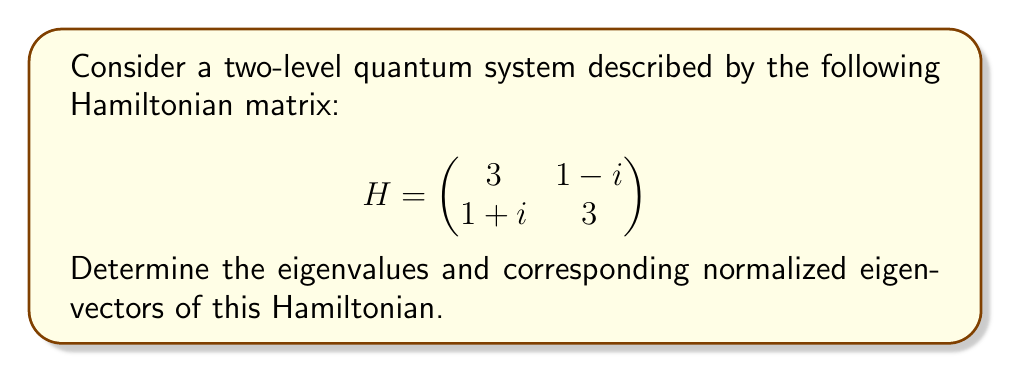Provide a solution to this math problem. To find the eigenvalues and eigenvectors of the Hamiltonian matrix, we'll follow these steps:

1. Find the characteristic equation:
   $$\det(H - \lambda I) = 0$$
   
   $$\begin{vmatrix}
   3-\lambda & 1-i \\
   1+i & 3-\lambda
   \end{vmatrix} = 0$$

2. Expand the determinant:
   $$(3-\lambda)^2 - (1-i)(1+i) = 0$$
   $$(3-\lambda)^2 - (1+1) = 0$$
   $$(3-\lambda)^2 - 2 = 0$$

3. Solve for $\lambda$:
   $(3-\lambda)^2 = 2$
   $3-\lambda = \pm\sqrt{2}$
   $\lambda = 3 \pm \sqrt{2}$

4. The eigenvalues are:
   $\lambda_1 = 3 + \sqrt{2}$ and $\lambda_2 = 3 - \sqrt{2}$

5. For each eigenvalue, find the corresponding eigenvector by solving $(H - \lambda I)v = 0$:

   For $\lambda_1 = 3 + \sqrt{2}$:
   $$\begin{pmatrix}
   -\sqrt{2} & 1-i \\
   1+i & -\sqrt{2}
   \end{pmatrix}\begin{pmatrix}
   v_1 \\
   v_2
   \end{pmatrix} = \begin{pmatrix}
   0 \\
   0
   \end{pmatrix}$$

   Solving this gives: $v_1 = 1-i$, $v_2 = \sqrt{2}$

   For $\lambda_2 = 3 - \sqrt{2}$:
   $$\begin{pmatrix}
   \sqrt{2} & 1-i \\
   1+i & \sqrt{2}
   \end{pmatrix}\begin{pmatrix}
   v_1 \\
   v_2
   \end{pmatrix} = \begin{pmatrix}
   0 \\
   0
   \end{pmatrix}$$

   Solving this gives: $v_1 = 1+i$, $v_2 = \sqrt{2}$

6. Normalize the eigenvectors:
   For $\lambda_1$: $\|\vec{v_1}\| = \sqrt{(1-i)(1+i) + 2} = \sqrt{4} = 2$
   Normalized: $\vec{v_1} = \frac{1}{2}(1-i, \sqrt{2})$

   For $\lambda_2$: $\|\vec{v_2}\| = \sqrt{(1+i)(1-i) + 2} = \sqrt{4} = 2$
   Normalized: $\vec{v_2} = \frac{1}{2}(1+i, \sqrt{2})$
Answer: Eigenvalues: $\lambda_1 = 3 + \sqrt{2}$, $\lambda_2 = 3 - \sqrt{2}$
Normalized eigenvectors: $\vec{v_1} = \frac{1}{2}(1-i, \sqrt{2})$, $\vec{v_2} = \frac{1}{2}(1+i, \sqrt{2})$ 